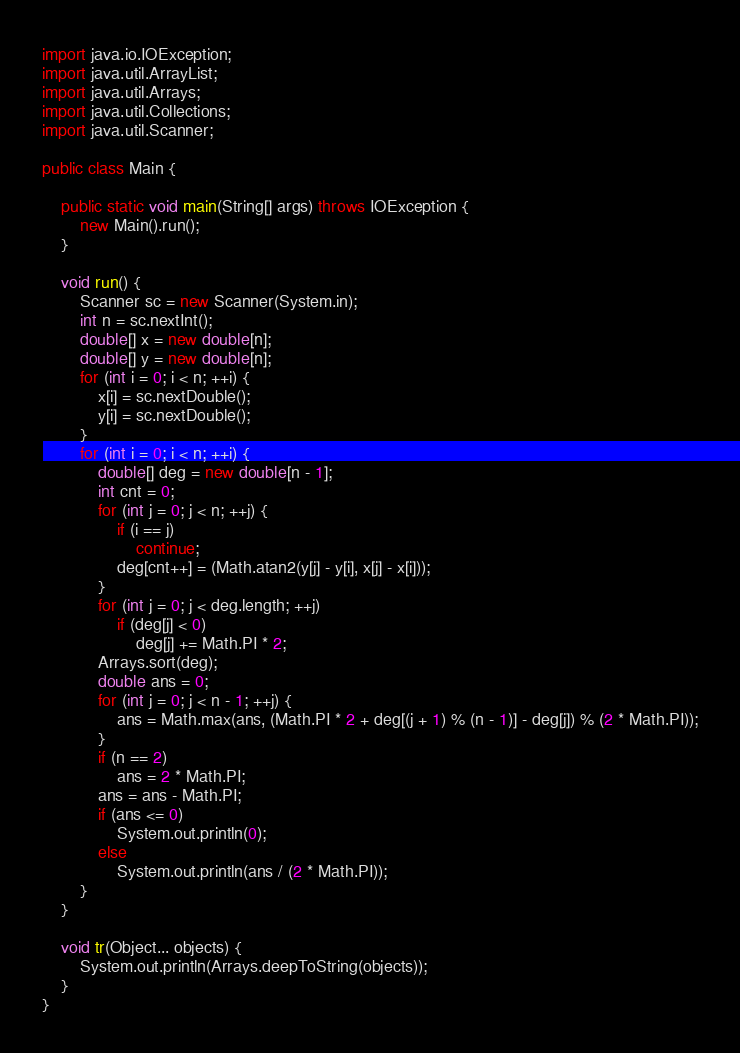<code> <loc_0><loc_0><loc_500><loc_500><_Java_>import java.io.IOException;
import java.util.ArrayList;
import java.util.Arrays;
import java.util.Collections;
import java.util.Scanner;

public class Main {

	public static void main(String[] args) throws IOException {
		new Main().run();
	}

	void run() {
		Scanner sc = new Scanner(System.in);
		int n = sc.nextInt();
		double[] x = new double[n];
		double[] y = new double[n];
		for (int i = 0; i < n; ++i) {
			x[i] = sc.nextDouble();
			y[i] = sc.nextDouble();
		}
		for (int i = 0; i < n; ++i) {
			double[] deg = new double[n - 1];
			int cnt = 0;
			for (int j = 0; j < n; ++j) {
				if (i == j)
					continue;
				deg[cnt++] = (Math.atan2(y[j] - y[i], x[j] - x[i]));
			}
			for (int j = 0; j < deg.length; ++j)
				if (deg[j] < 0)
					deg[j] += Math.PI * 2;
			Arrays.sort(deg);
			double ans = 0;
			for (int j = 0; j < n - 1; ++j) {
				ans = Math.max(ans, (Math.PI * 2 + deg[(j + 1) % (n - 1)] - deg[j]) % (2 * Math.PI));
			}
			if (n == 2)
				ans = 2 * Math.PI;
			ans = ans - Math.PI;
			if (ans <= 0)
				System.out.println(0);
			else
				System.out.println(ans / (2 * Math.PI));
		}
	}

	void tr(Object... objects) {
		System.out.println(Arrays.deepToString(objects));
	}
}</code> 